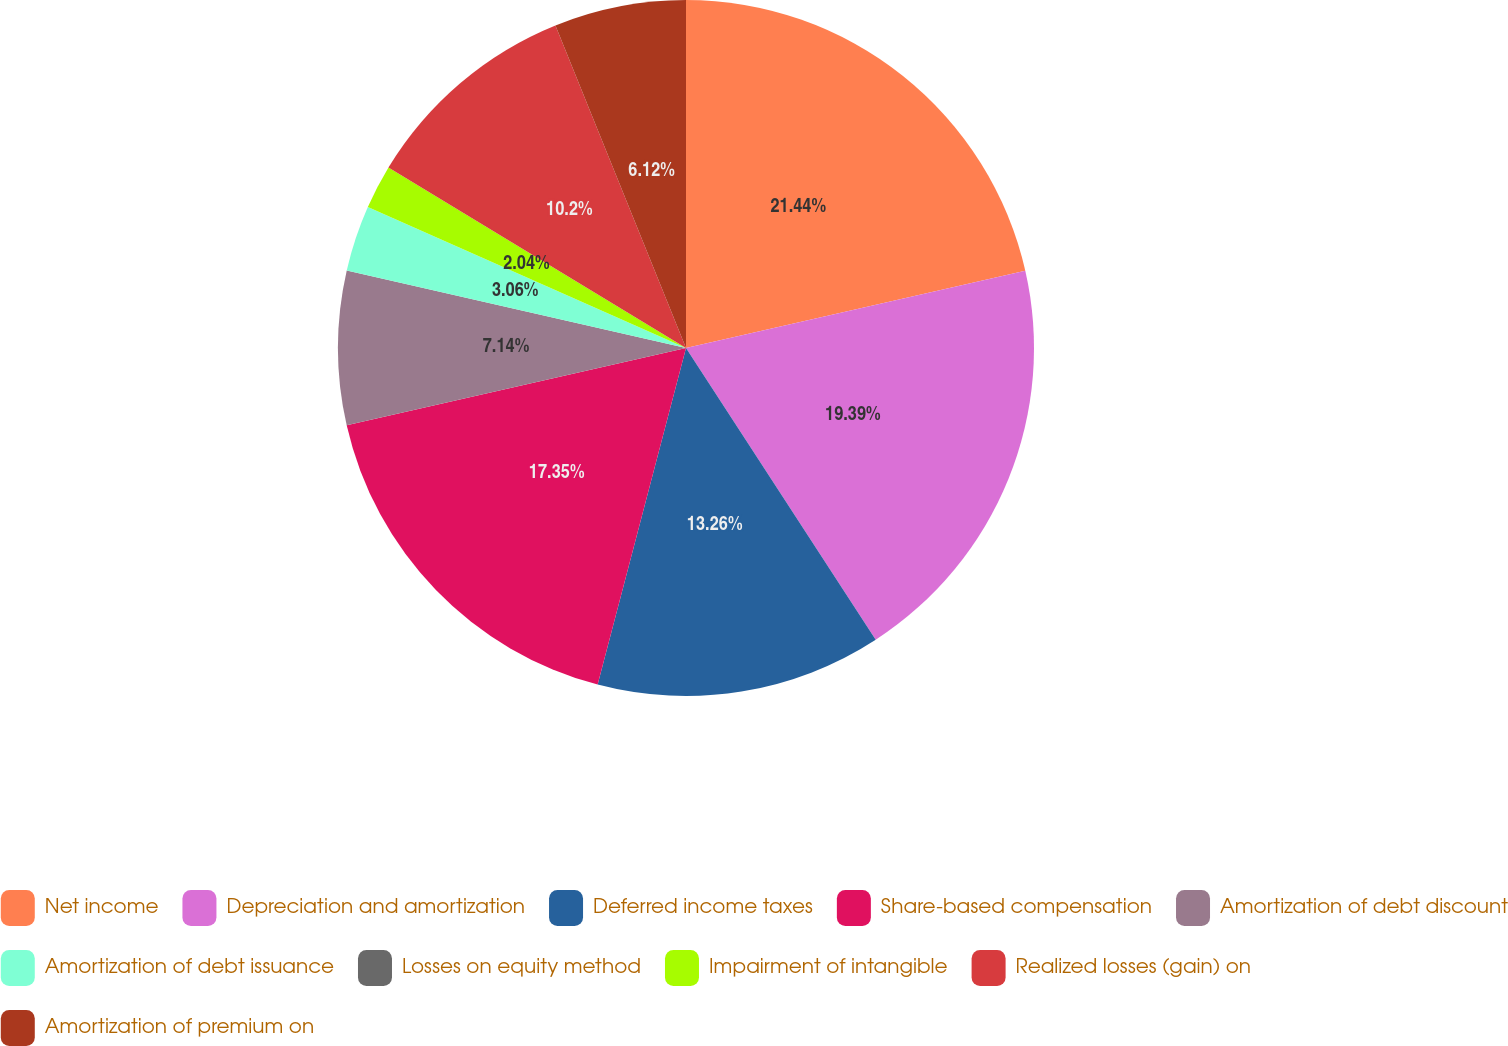Convert chart. <chart><loc_0><loc_0><loc_500><loc_500><pie_chart><fcel>Net income<fcel>Depreciation and amortization<fcel>Deferred income taxes<fcel>Share-based compensation<fcel>Amortization of debt discount<fcel>Amortization of debt issuance<fcel>Losses on equity method<fcel>Impairment of intangible<fcel>Realized losses (gain) on<fcel>Amortization of premium on<nl><fcel>21.43%<fcel>19.39%<fcel>13.26%<fcel>17.35%<fcel>7.14%<fcel>3.06%<fcel>0.0%<fcel>2.04%<fcel>10.2%<fcel>6.12%<nl></chart> 